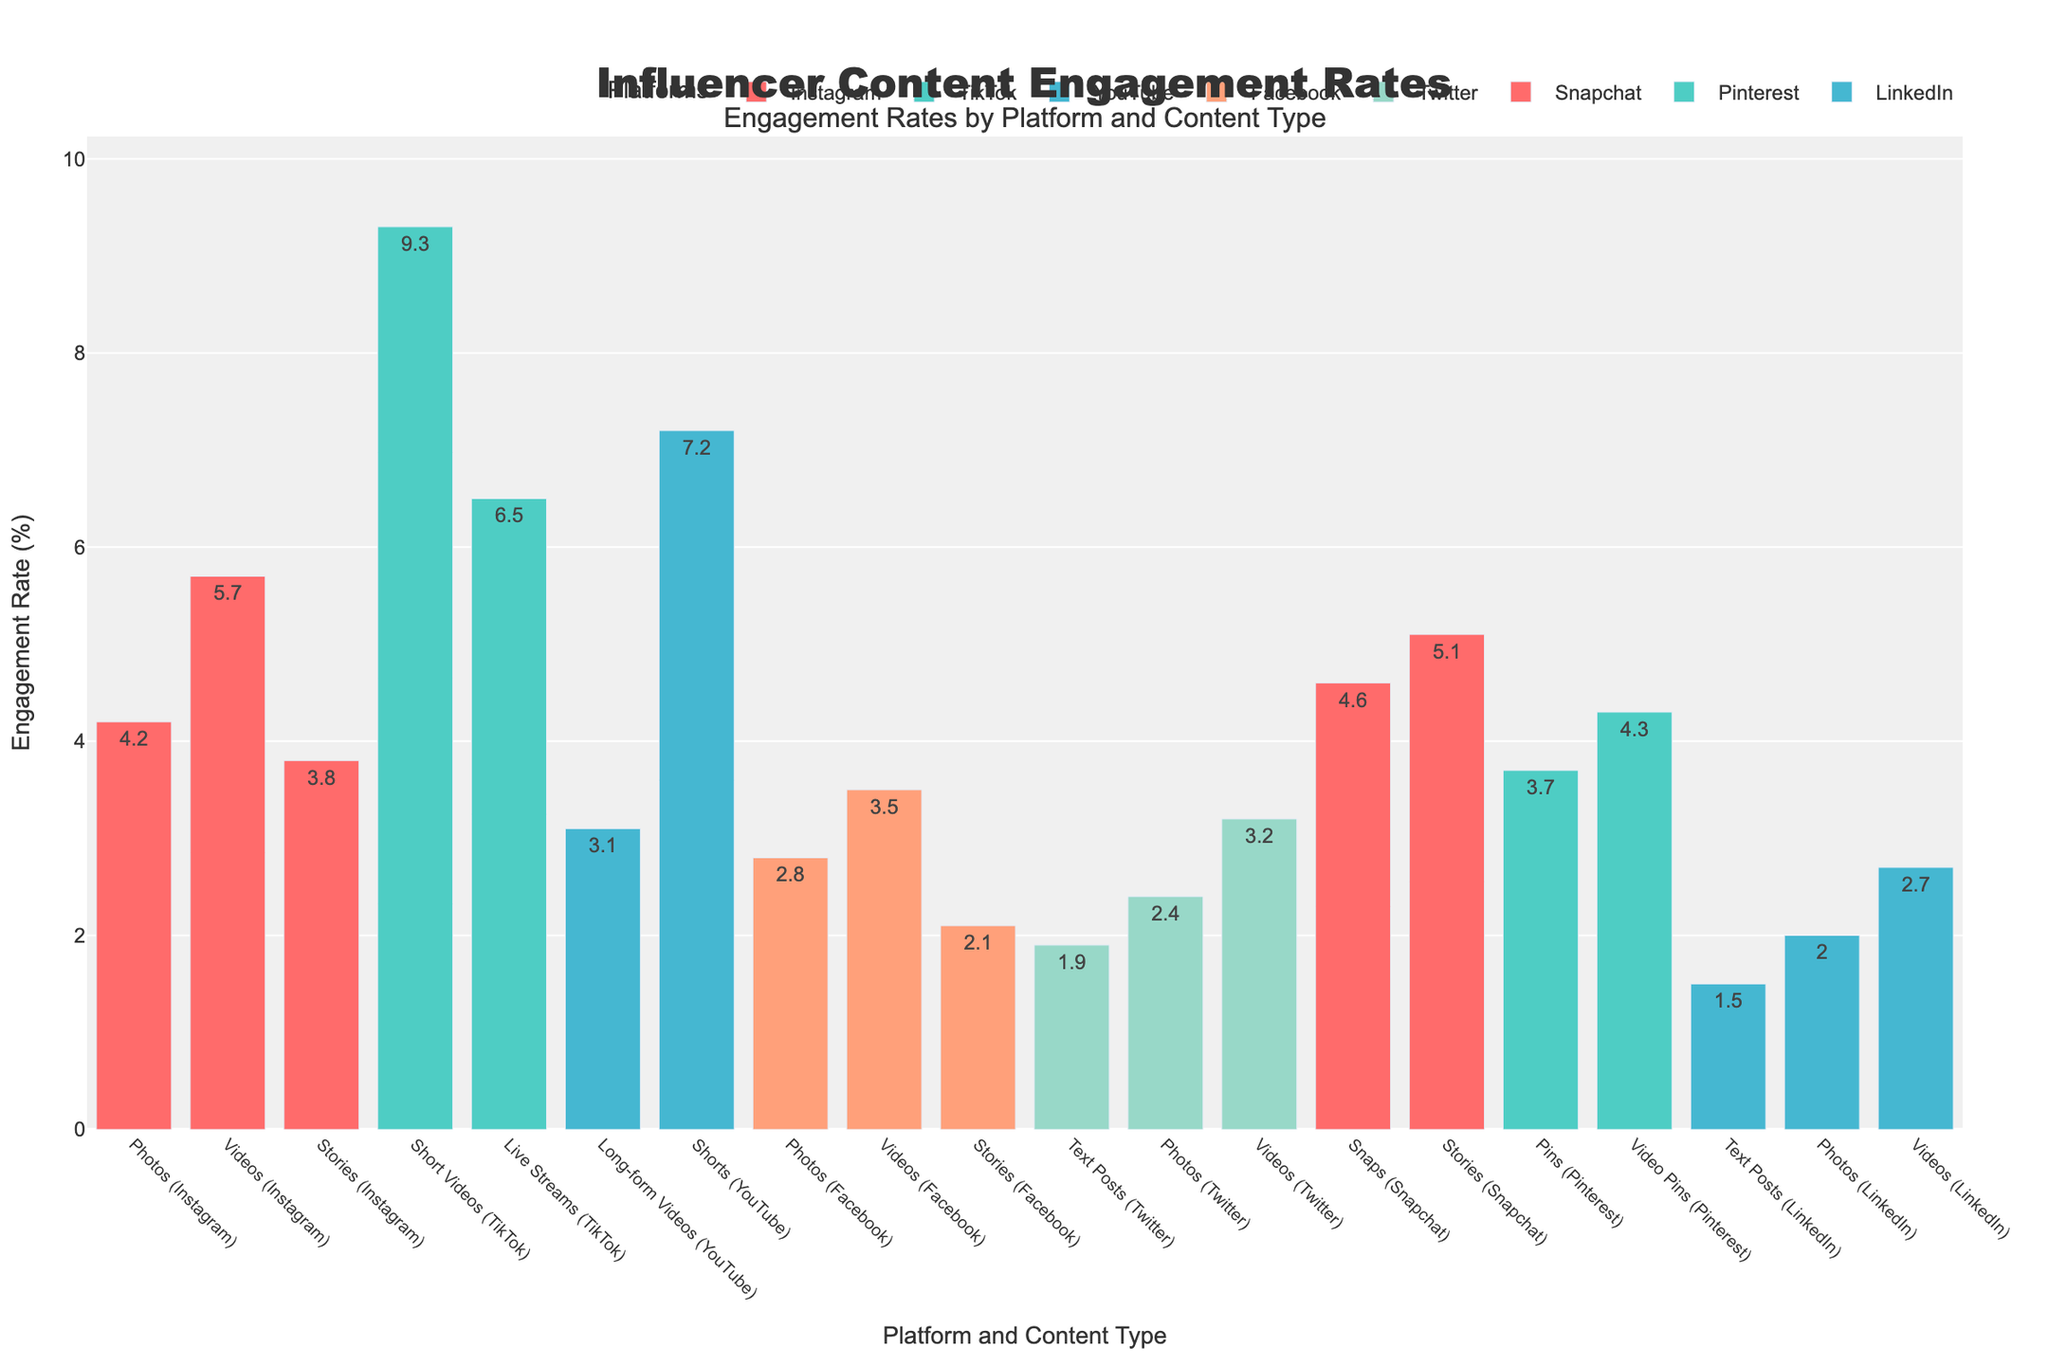Which platform has the highest engagement rate for videos? To determine which platform has the highest engagement rate for videos, compare the engagement rates specifically for video content across all platforms. TikTok has the highest rate at 9.3%.
Answer: TikTok Which has a higher engagement rate on Instagram, photos or stories? On Instagram, the engagement rate for photos is 4.2% while for stories it is 3.8%. Therefore, photos have a higher engagement rate than stories.
Answer: Photos What is the average engagement rate for video content across all platforms? To find the average engagement rate for video content across all platforms, add the engagement rates of video content (5.7% Instagram, 9.3% TikTok, 3.1% YouTube, 3.5% Facebook, 3.2% Twitter, 4.3% Pinterest, 2.7% LinkedIn) and divide by the number of platforms. (5.7 + 9.3 + 3.1 + 3.5 + 3.2 + 4.3 + 2.7) / 7 = 4.54
Answer: 4.54 Compare the engagement rates between Instagram stories and Snapchat stories. Which one is higher? The engagement rate for Instagram stories is 3.8%, whereas for Snapchat stories it is 5.1%. Therefore, Snapchat stories have a higher engagement rate.
Answer: Snapchat Which content type has the lowest engagement rate on LinkedIn? Among LinkedIn content types, the engagement rates are 1.5% for text posts, 2.0% for photos, and 2.7% for videos. Text posts have the lowest engagement rate.
Answer: Text posts Between TikTok and YouTube, which platform has the higher average engagement rate for all their content types? TikTok has engagement rates of 9.3% (Short Videos) and 6.5% (Live Streams), averaging (9.3 + 6.5) / 2 = 7.9%. YouTube has engagement rates of 3.1% (Long-form Videos) and 7.2% (Shorts), averaging (3.1 + 7.2) / 2 = 5.15%. TikTok has the higher average engagement rate.
Answer: TikTok What is the difference in engagement rates between Twitter text posts and LinkedIn text posts? Twitter text posts have an engagement rate of 1.9%, while LinkedIn text posts have an engagement rate of 1.5%. The difference is 1.9% - 1.5% = 0.4%.
Answer: 0.4% Which content type and platform combination has the highest engagement rate? By evaluating all engagement rates, TikTok Short Videos have the highest engagement rate of 9.3%.
Answer: TikTok Short Videos How much higher is the engagement rate for Facebook videos compared to Facebook stories? The engagement rate for Facebook videos is 3.5%, while for Facebook stories it is 2.1%. The difference is 3.5% - 2.1% = 1.4%.
Answer: 1.4% What is the total engagement rate for all content types on Snapchat? The total engagement rate for Snapchat includes snaps at 4.6% and stories at 5.1%. Adding them gives 4.6 + 5.1 = 9.7%.
Answer: 9.7 